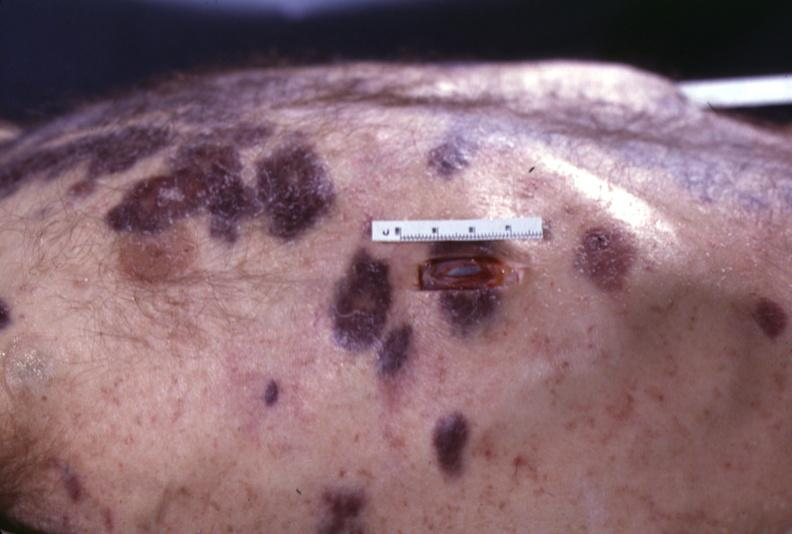what does this image show?
Answer the question using a single word or phrase. Skin 